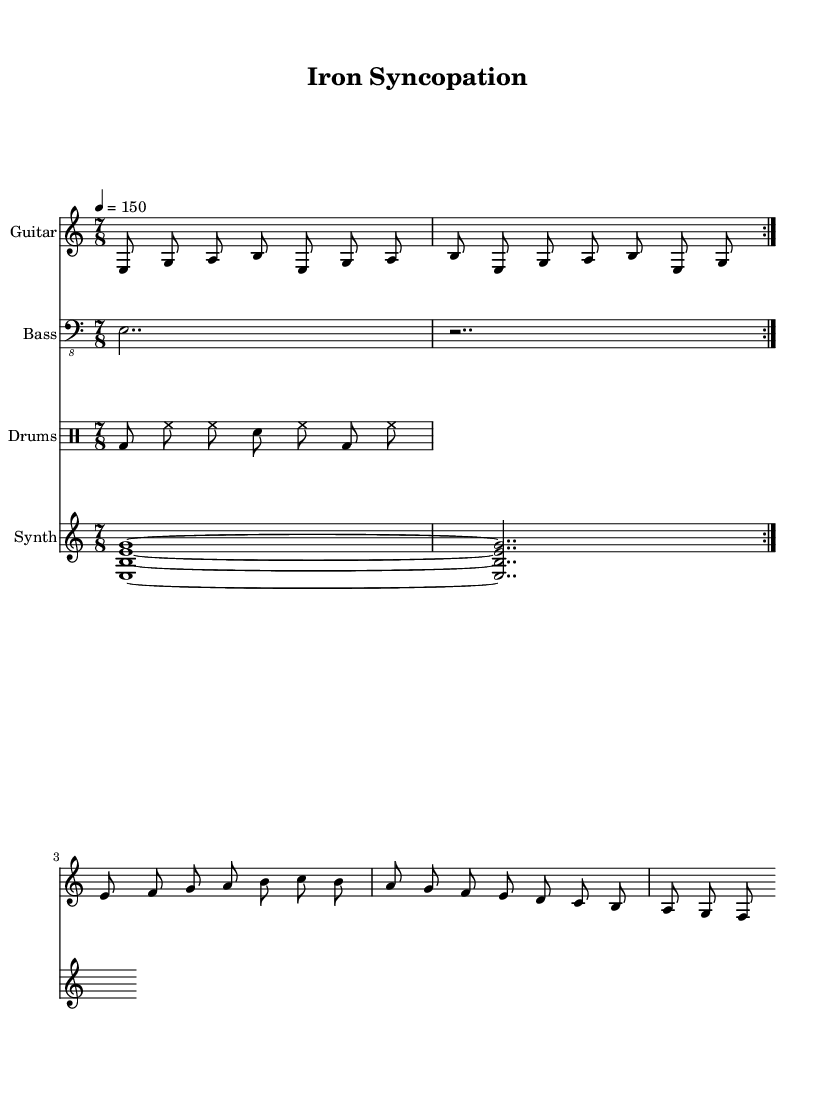What is the key signature of this music? The key signature indicated in the music is E Phrygian, which typically includes the notes E, F, G, A, B, C, and D.
Answer: E Phrygian What is the time signature of this piece? The time signature shown is 7/8, which means there are 7 beats in a measure, and the eighth note gets one beat.
Answer: 7/8 What is the tempo marking of this composition? The tempo marking in the score states that the piece should be played at 150 beats per minute, indicating a fairly brisk pace.
Answer: 150 How many measures are in the guitar riff section? The guitar riff section consists of two measures, as indicated by the repeat notation, meaning it is played twice.
Answer: 2 What instruments are included in the score? The score includes four instruments: Guitar, Bass, Drums, and Synth, as each has its own staff labeled accordingly.
Answer: Guitar, Bass, Drums, Synth What type of rhythmic pattern is used in the drum section? The drum section features a rhythm pattern consisting of bass drum, hi-hat, and snare hits, which are typical in progressive metal music for complex rhythms.
Answer: Syncopated What is the final note of the guitar melody? The final note of the guitar melody in the score is a B, which resolves at the end of the melodic line.
Answer: B 